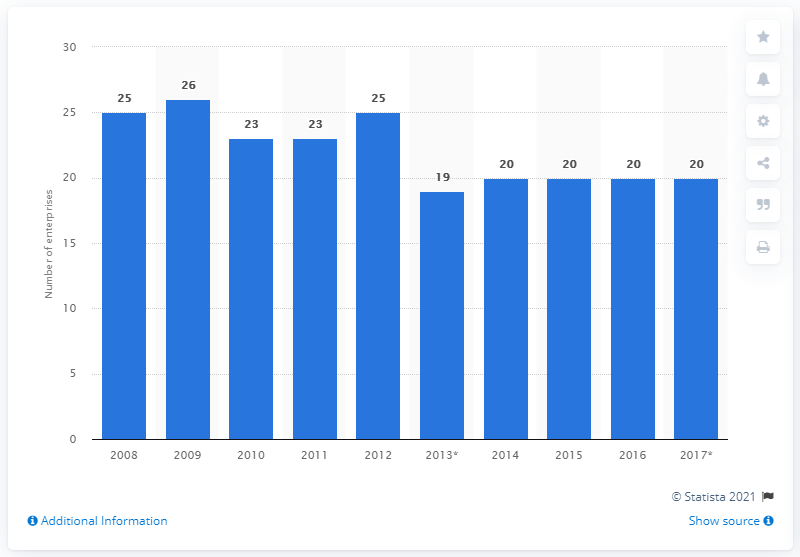Indicate a few pertinent items in this graphic. There were 20 enterprises in Finland that manufactured electric domestic appliances from 2008 to 2017. 